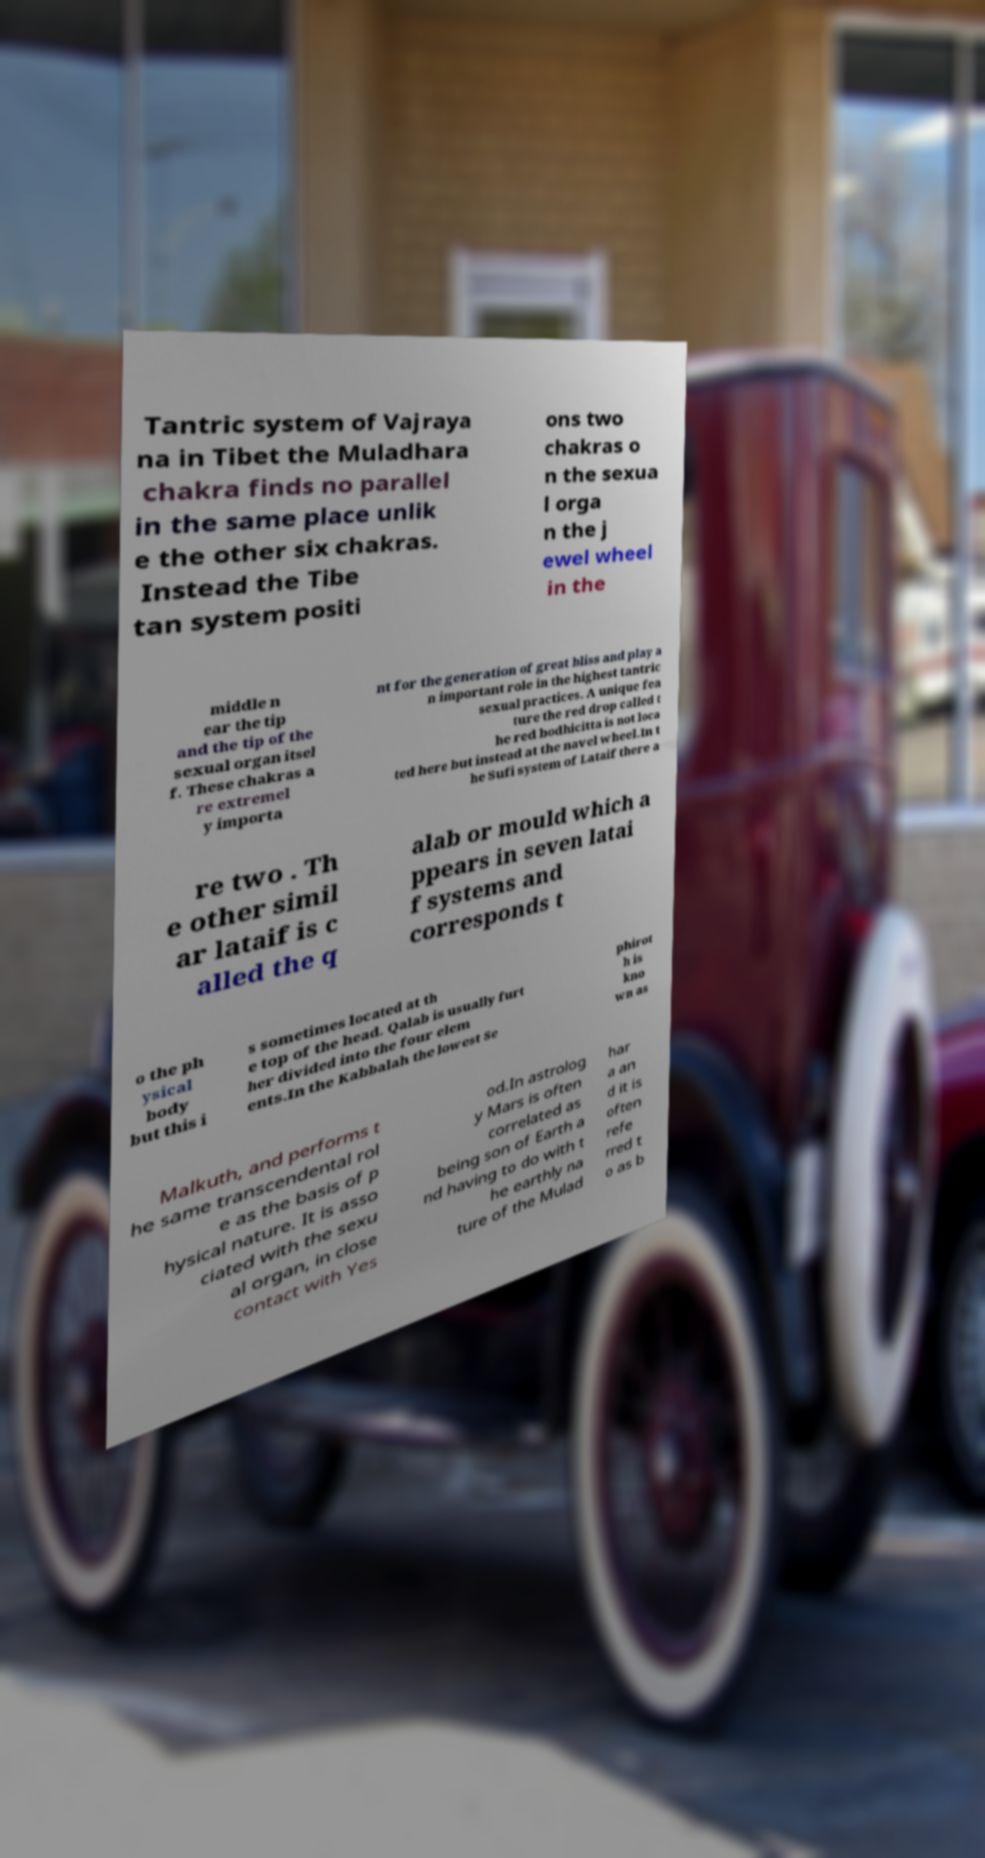Could you assist in decoding the text presented in this image and type it out clearly? Tantric system of Vajraya na in Tibet the Muladhara chakra finds no parallel in the same place unlik e the other six chakras. Instead the Tibe tan system positi ons two chakras o n the sexua l orga n the j ewel wheel in the middle n ear the tip and the tip of the sexual organ itsel f. These chakras a re extremel y importa nt for the generation of great bliss and play a n important role in the highest tantric sexual practices. A unique fea ture the red drop called t he red bodhicitta is not loca ted here but instead at the navel wheel.In t he Sufi system of Lataif there a re two . Th e other simil ar lataif is c alled the q alab or mould which a ppears in seven latai f systems and corresponds t o the ph ysical body but this i s sometimes located at th e top of the head. Qalab is usually furt her divided into the four elem ents.In the Kabbalah the lowest Se phirot h is kno wn as Malkuth, and performs t he same transcendental rol e as the basis of p hysical nature. It is asso ciated with the sexu al organ, in close contact with Yes od.In astrolog y Mars is often correlated as being son of Earth a nd having to do with t he earthly na ture of the Mulad har a an d it is often refe rred t o as b 